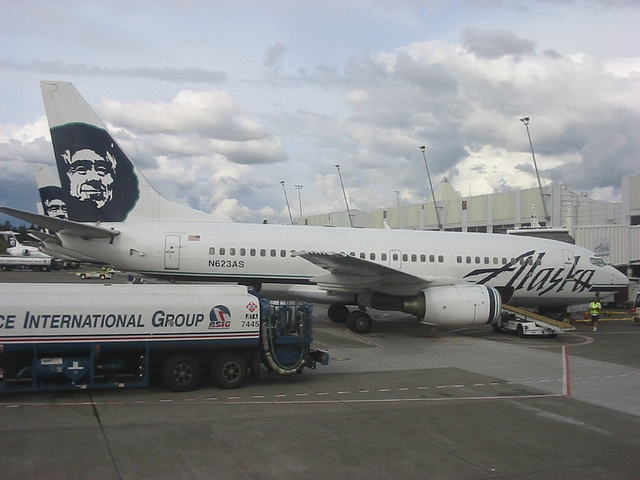Describe the objects in this image and their specific colors. I can see airplane in darkgray, lightgray, gray, and black tones, truck in darkgray, black, and gray tones, people in darkgray, black, gray, darkgreen, and olive tones, and car in darkgray, gray, and black tones in this image. 